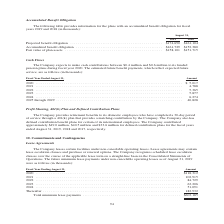According to Jabil Circuit's financial document, What was the fair value of plan assets in 2019? According to the financial document, $158,101 (in thousands). The relevant text states: "on . $161,729 $152,380 Fair value of plan assets . $158,101 $151,715..." Also, Which years does the table provide information for the plans with an accumulated benefit obligation for? The document shows two values: 2019 and 2018. From the document: "n accumulated benefit obligation for fiscal years 2019 and 2018 (in thousands): ated benefit obligation for fiscal years 2019 and 2018 (in thousands):..." Also, What was the Accumulated benefit obligation in 2018? According to the financial document, $152,380 (in thousands). The relevant text states: "$161,104 Accumulated benefit obligation . $161,729 $152,380 Fair value of plan assets . $158,101 $151,715..." Also, can you calculate: What was the change in Accumulated benefit obligation between 2018 and 2019? Based on the calculation: $161,729-$152,380, the result is 9349 (in thousands). This is based on the information: "61,104 Accumulated benefit obligation . $161,729 $152,380 Fair value of plan assets . $158,101 $151,715 74,690 $161,104 Accumulated benefit obligation . $161,729 $152,380 Fair value of plan assets . $..." The key data points involved are: 152,380, 161,729. Also, How many years did the Projected benefit obligation exceed $150,000 thousand? Counting the relevant items in the document: 2019, 2018, I find 2 instances. The key data points involved are: 2018, 2019. Also, can you calculate: What was the percentage change in the fair value of plan assets between 2018 and 2019? To answer this question, I need to perform calculations using the financial data. The calculation is: ($158,101-$151,715)/$151,715, which equals 4.21 (percentage). This is based on the information: ". $161,729 $152,380 Fair value of plan assets . $158,101 $151,715 29 $152,380 Fair value of plan assets . $158,101 $151,715..." The key data points involved are: 151,715, 158,101. 